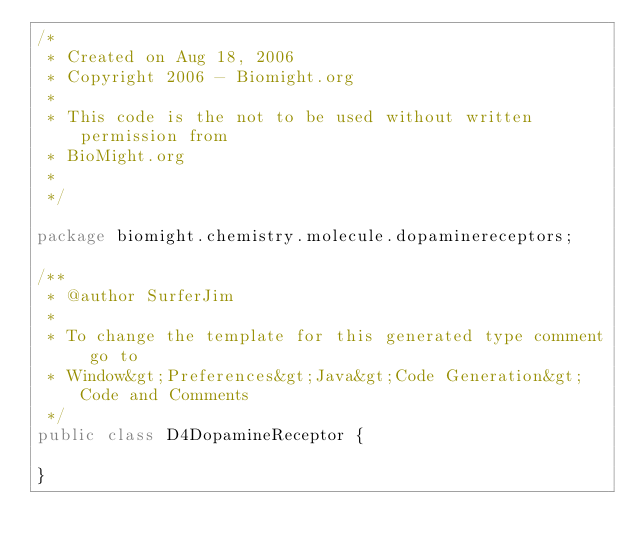Convert code to text. <code><loc_0><loc_0><loc_500><loc_500><_Java_>/*
 * Created on Aug 18, 2006
 * Copyright 2006 - Biomight.org
 * 
 * This code is the not to be used without written permission from
 * BioMight.org
 * 
 */
 
package biomight.chemistry.molecule.dopaminereceptors;

/**
 * @author SurferJim
 *
 * To change the template for this generated type comment go to
 * Window&gt;Preferences&gt;Java&gt;Code Generation&gt;Code and Comments
 */
public class D4DopamineReceptor {

}
</code> 